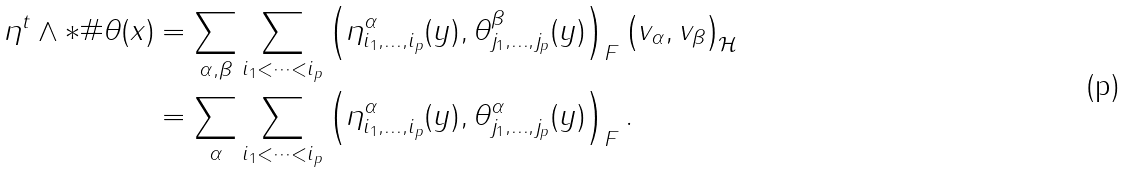Convert formula to latex. <formula><loc_0><loc_0><loc_500><loc_500>\eta ^ { t } \wedge * \# \theta ( x ) & = \sum _ { \alpha , \beta } \sum _ { i _ { 1 } < \dots < i _ { p } } \left ( \eta ^ { \alpha } _ { i _ { 1 } , \dots , i _ { p } } ( y ) , \theta ^ { \beta } _ { j _ { 1 } , \dots , j _ { p } } ( y ) \right ) _ { F } \left ( v _ { \alpha } , v _ { \beta } \right ) _ { \mathcal { H } } \\ & = \sum _ { \alpha } \sum _ { i _ { 1 } < \dots < i _ { p } } \left ( \eta ^ { \alpha } _ { i _ { 1 } , \dots , i _ { p } } ( y ) , \theta ^ { \alpha } _ { j _ { 1 } , \dots , j _ { p } } ( y ) \right ) _ { F } .</formula> 